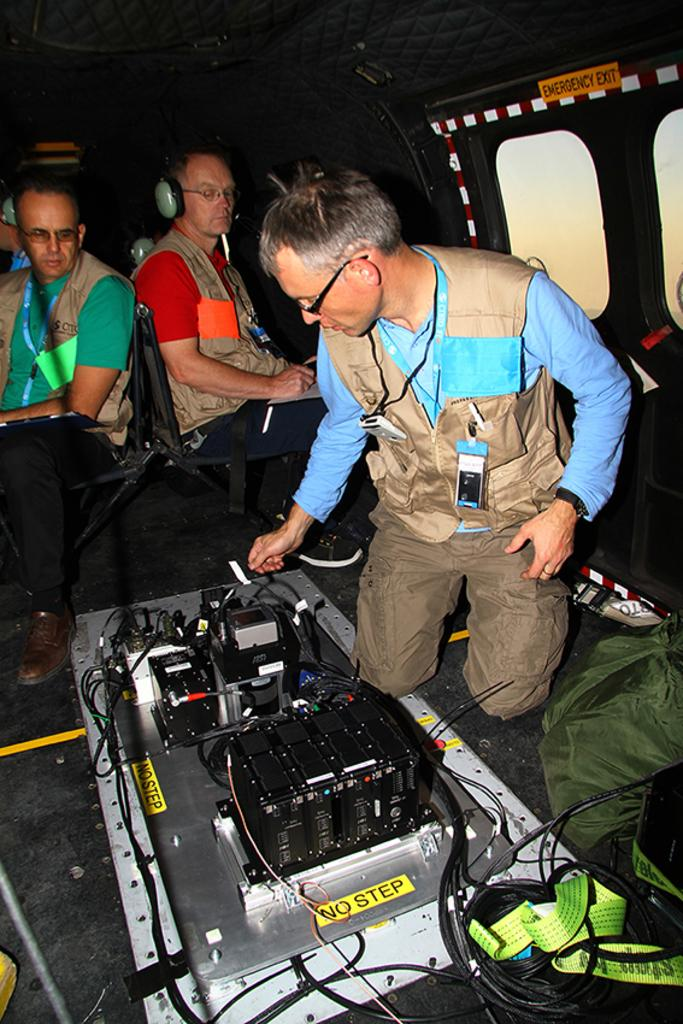What is the setting of the image? The image is inside a vehicle. Who or what can be seen in the image? There are people in the image. What feature of the vehicle is visible in the image? There are windows in the vehicle. What is the person in front holding? In front of a person, there is a device. What type of accessory is present in the image? Cables are present in the image. What object can be used for carrying items in the image? There is a bag in the image. What type of orange is being used as a paperweight in the image? There is no orange present in the image; it is not being used as a paperweight or for any other purpose. 